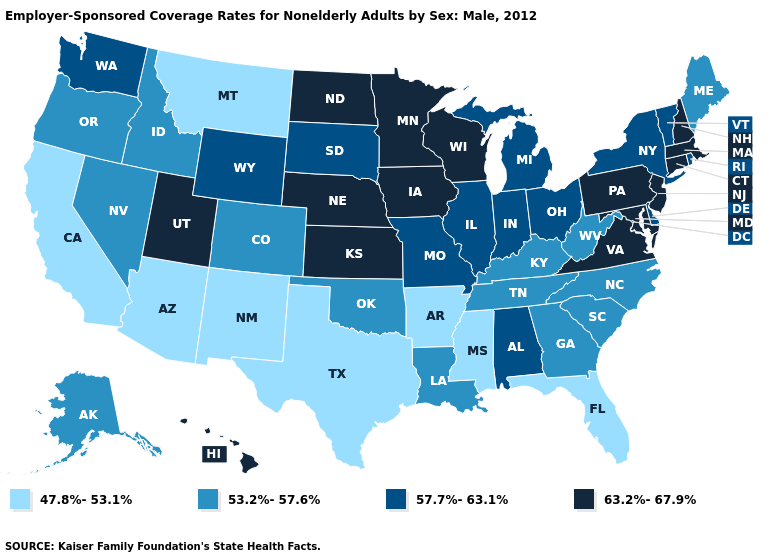How many symbols are there in the legend?
Quick response, please. 4. What is the lowest value in the USA?
Short answer required. 47.8%-53.1%. Among the states that border Missouri , does Tennessee have the highest value?
Write a very short answer. No. Among the states that border Florida , does Alabama have the lowest value?
Give a very brief answer. No. What is the value of Minnesota?
Write a very short answer. 63.2%-67.9%. Does the map have missing data?
Give a very brief answer. No. What is the highest value in the West ?
Answer briefly. 63.2%-67.9%. Name the states that have a value in the range 47.8%-53.1%?
Give a very brief answer. Arizona, Arkansas, California, Florida, Mississippi, Montana, New Mexico, Texas. Name the states that have a value in the range 63.2%-67.9%?
Short answer required. Connecticut, Hawaii, Iowa, Kansas, Maryland, Massachusetts, Minnesota, Nebraska, New Hampshire, New Jersey, North Dakota, Pennsylvania, Utah, Virginia, Wisconsin. What is the value of Massachusetts?
Quick response, please. 63.2%-67.9%. What is the value of Oregon?
Be succinct. 53.2%-57.6%. What is the value of Maryland?
Give a very brief answer. 63.2%-67.9%. Name the states that have a value in the range 63.2%-67.9%?
Quick response, please. Connecticut, Hawaii, Iowa, Kansas, Maryland, Massachusetts, Minnesota, Nebraska, New Hampshire, New Jersey, North Dakota, Pennsylvania, Utah, Virginia, Wisconsin. Does the first symbol in the legend represent the smallest category?
Give a very brief answer. Yes. Which states have the lowest value in the South?
Be succinct. Arkansas, Florida, Mississippi, Texas. 